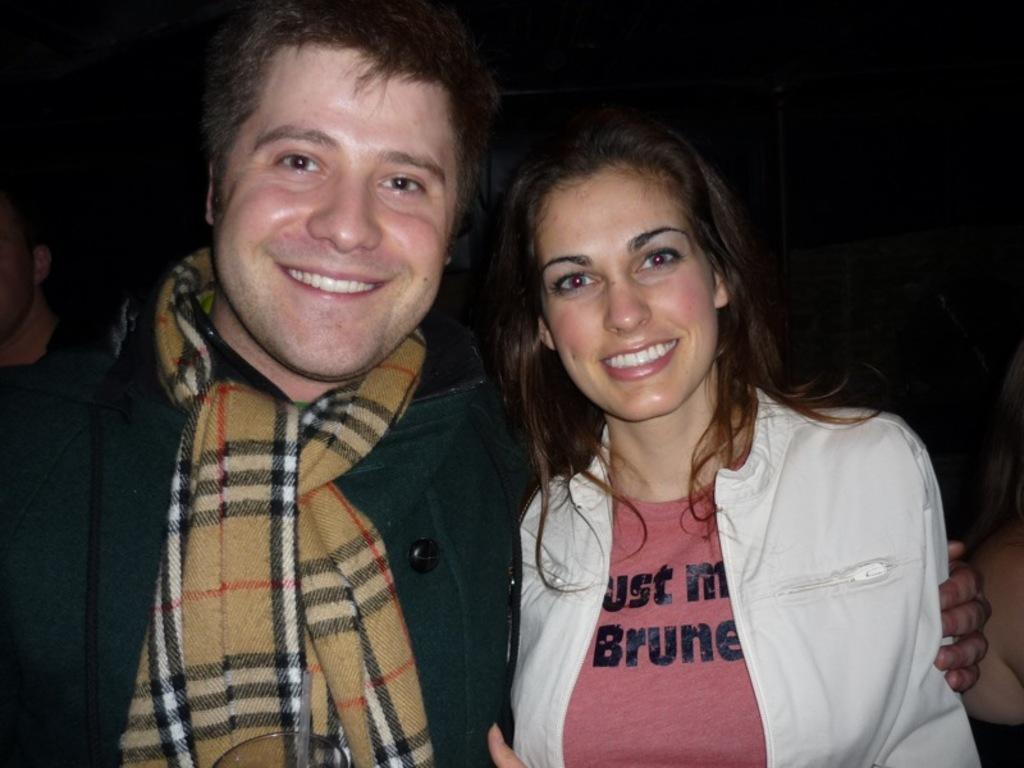What are the main subjects in the foreground of the image? There is a man and a woman in the foreground of the image. What are the expressions on their faces? Both the man and woman are smiling in the image. Are there any other people visible in the image? Yes, there are additional persons in the background of the image. What type of body is visible in the image? There is no specific body present in the image; it features people, but not a single body. Can you tell me how many stitches are used to create the woman's dress in the image? There is no information about the woman's dress or its construction in the image, so it is impossible to determine the number of stitches. 